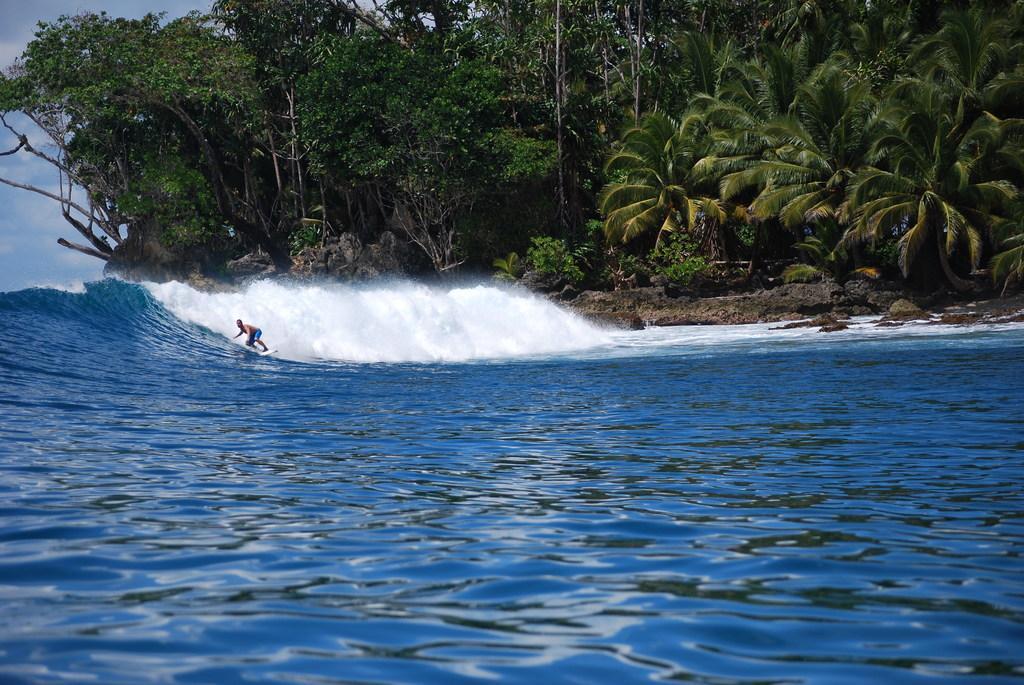Can you describe this image briefly? In the image we can see there is an ocean and there is a person standing on the surfing board. There are waves in the ocean and behind there are lot of trees. There is a cloudy sky. 